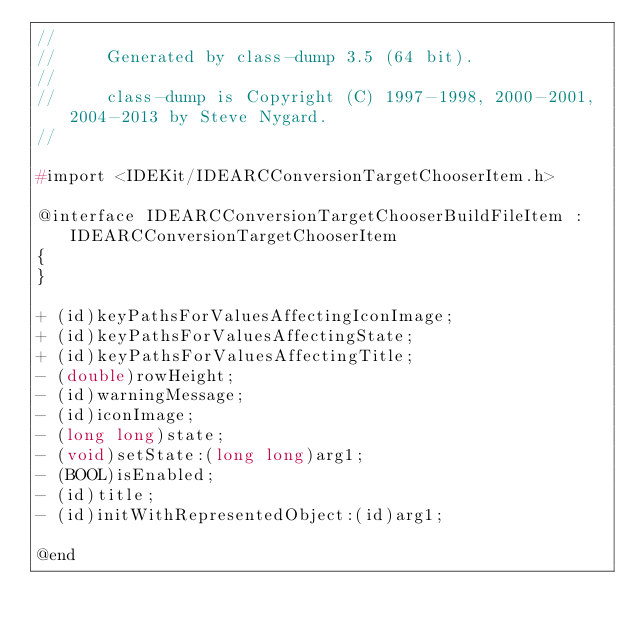<code> <loc_0><loc_0><loc_500><loc_500><_C_>//
//     Generated by class-dump 3.5 (64 bit).
//
//     class-dump is Copyright (C) 1997-1998, 2000-2001, 2004-2013 by Steve Nygard.
//

#import <IDEKit/IDEARCConversionTargetChooserItem.h>

@interface IDEARCConversionTargetChooserBuildFileItem : IDEARCConversionTargetChooserItem
{
}

+ (id)keyPathsForValuesAffectingIconImage;
+ (id)keyPathsForValuesAffectingState;
+ (id)keyPathsForValuesAffectingTitle;
- (double)rowHeight;
- (id)warningMessage;
- (id)iconImage;
- (long long)state;
- (void)setState:(long long)arg1;
- (BOOL)isEnabled;
- (id)title;
- (id)initWithRepresentedObject:(id)arg1;

@end

</code> 